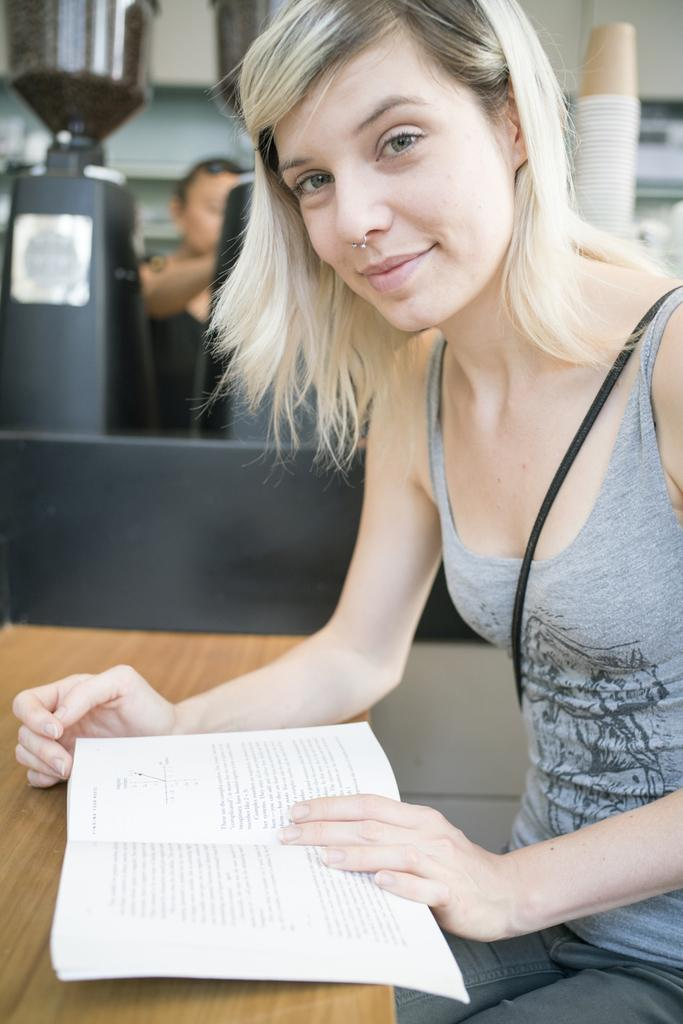What is the woman doing in the image? The woman is sitting at the table in the image. What is the woman holding or using in the image? The woman has a book with her. What can be seen in the background of the image? There are coffee machines, cups, and a person in the background of the image. What is the setting of the image? There is a wall in the background of the image, suggesting an indoor setting. Can you describe the vase on the table in the image? There is no vase present on the table in the image. Is the woman swimming in the image? No, the woman is sitting at the table, not swimming. 